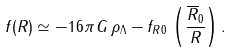<formula> <loc_0><loc_0><loc_500><loc_500>f ( R ) \simeq - 1 6 \pi \, G \, \rho _ { \Lambda } - f _ { R 0 } \, \left ( \frac { \overline { R } _ { 0 } } { R } \right ) .</formula> 